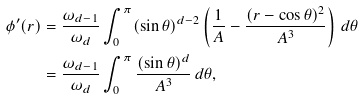<formula> <loc_0><loc_0><loc_500><loc_500>\phi ^ { \prime } ( r ) & = \frac { \omega _ { d - 1 } } { \omega _ { d } } \int _ { 0 } ^ { \pi } ( \sin \theta ) ^ { d - 2 } \left ( \frac { 1 } { A } - \frac { ( r - \cos \theta ) ^ { 2 } } { A ^ { 3 } } \right ) \, d \theta \\ & = \frac { \omega _ { d - 1 } } { \omega _ { d } } \int _ { 0 } ^ { \pi } \frac { ( \sin \theta ) ^ { d } } { A ^ { 3 } } \, d \theta ,</formula> 